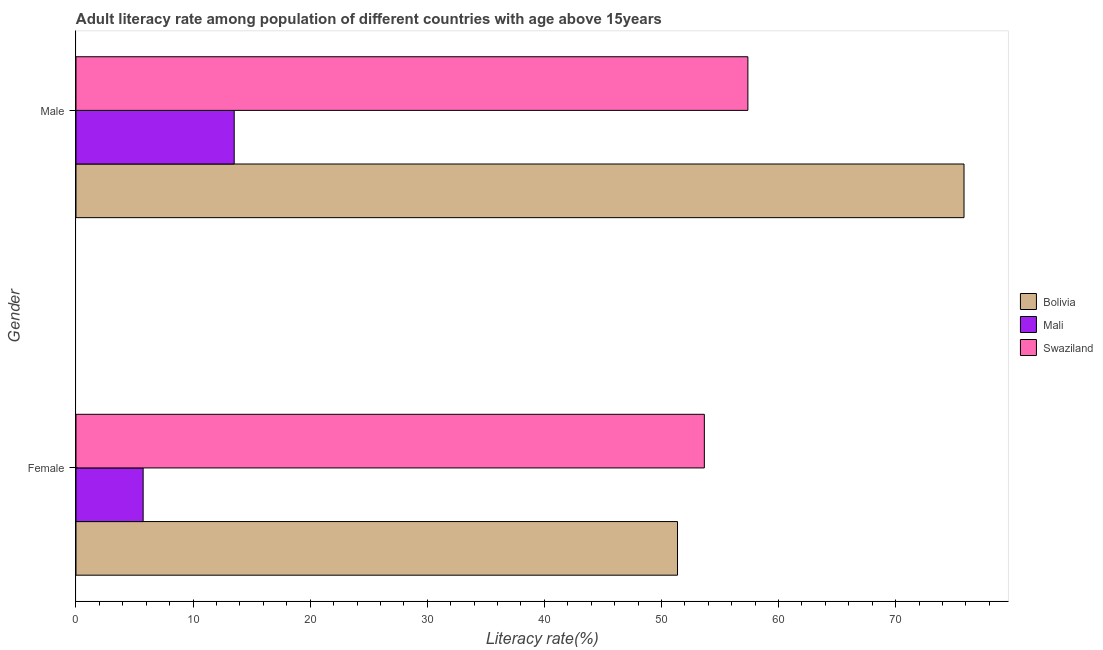How many groups of bars are there?
Keep it short and to the point. 2. Are the number of bars per tick equal to the number of legend labels?
Offer a very short reply. Yes. What is the female adult literacy rate in Mali?
Offer a terse response. 5.74. Across all countries, what is the maximum male adult literacy rate?
Offer a very short reply. 75.84. Across all countries, what is the minimum female adult literacy rate?
Make the answer very short. 5.74. In which country was the male adult literacy rate minimum?
Provide a short and direct response. Mali. What is the total male adult literacy rate in the graph?
Your answer should be compact. 146.74. What is the difference between the female adult literacy rate in Swaziland and that in Mali?
Ensure brevity in your answer.  47.93. What is the difference between the male adult literacy rate in Bolivia and the female adult literacy rate in Swaziland?
Offer a terse response. 22.18. What is the average male adult literacy rate per country?
Provide a succinct answer. 48.91. What is the difference between the male adult literacy rate and female adult literacy rate in Bolivia?
Ensure brevity in your answer.  24.47. What is the ratio of the female adult literacy rate in Swaziland to that in Mali?
Your answer should be very brief. 9.36. What does the 3rd bar from the top in Male represents?
Provide a short and direct response. Bolivia. What does the 2nd bar from the bottom in Female represents?
Ensure brevity in your answer.  Mali. How many countries are there in the graph?
Your answer should be very brief. 3. Does the graph contain any zero values?
Your answer should be compact. No. Where does the legend appear in the graph?
Make the answer very short. Center right. How are the legend labels stacked?
Your response must be concise. Vertical. What is the title of the graph?
Give a very brief answer. Adult literacy rate among population of different countries with age above 15years. What is the label or title of the X-axis?
Your answer should be compact. Literacy rate(%). What is the Literacy rate(%) of Bolivia in Female?
Offer a terse response. 51.37. What is the Literacy rate(%) in Mali in Female?
Offer a terse response. 5.74. What is the Literacy rate(%) in Swaziland in Female?
Keep it short and to the point. 53.67. What is the Literacy rate(%) in Bolivia in Male?
Ensure brevity in your answer.  75.84. What is the Literacy rate(%) of Mali in Male?
Your answer should be compact. 13.51. What is the Literacy rate(%) in Swaziland in Male?
Your answer should be compact. 57.38. Across all Gender, what is the maximum Literacy rate(%) in Bolivia?
Keep it short and to the point. 75.84. Across all Gender, what is the maximum Literacy rate(%) in Mali?
Offer a terse response. 13.51. Across all Gender, what is the maximum Literacy rate(%) in Swaziland?
Your response must be concise. 57.38. Across all Gender, what is the minimum Literacy rate(%) of Bolivia?
Provide a succinct answer. 51.37. Across all Gender, what is the minimum Literacy rate(%) in Mali?
Your answer should be very brief. 5.74. Across all Gender, what is the minimum Literacy rate(%) in Swaziland?
Provide a succinct answer. 53.67. What is the total Literacy rate(%) in Bolivia in the graph?
Provide a succinct answer. 127.22. What is the total Literacy rate(%) in Mali in the graph?
Provide a succinct answer. 19.25. What is the total Literacy rate(%) of Swaziland in the graph?
Your response must be concise. 111.05. What is the difference between the Literacy rate(%) in Bolivia in Female and that in Male?
Ensure brevity in your answer.  -24.47. What is the difference between the Literacy rate(%) in Mali in Female and that in Male?
Keep it short and to the point. -7.78. What is the difference between the Literacy rate(%) of Swaziland in Female and that in Male?
Your response must be concise. -3.72. What is the difference between the Literacy rate(%) in Bolivia in Female and the Literacy rate(%) in Mali in Male?
Make the answer very short. 37.86. What is the difference between the Literacy rate(%) of Bolivia in Female and the Literacy rate(%) of Swaziland in Male?
Provide a short and direct response. -6.01. What is the difference between the Literacy rate(%) of Mali in Female and the Literacy rate(%) of Swaziland in Male?
Keep it short and to the point. -51.65. What is the average Literacy rate(%) in Bolivia per Gender?
Your answer should be compact. 63.61. What is the average Literacy rate(%) of Mali per Gender?
Your answer should be compact. 9.62. What is the average Literacy rate(%) of Swaziland per Gender?
Your answer should be compact. 55.53. What is the difference between the Literacy rate(%) of Bolivia and Literacy rate(%) of Mali in Female?
Give a very brief answer. 45.64. What is the difference between the Literacy rate(%) in Bolivia and Literacy rate(%) in Swaziland in Female?
Provide a short and direct response. -2.29. What is the difference between the Literacy rate(%) in Mali and Literacy rate(%) in Swaziland in Female?
Offer a terse response. -47.93. What is the difference between the Literacy rate(%) of Bolivia and Literacy rate(%) of Mali in Male?
Offer a very short reply. 62.33. What is the difference between the Literacy rate(%) in Bolivia and Literacy rate(%) in Swaziland in Male?
Your answer should be compact. 18.46. What is the difference between the Literacy rate(%) in Mali and Literacy rate(%) in Swaziland in Male?
Offer a very short reply. -43.87. What is the ratio of the Literacy rate(%) of Bolivia in Female to that in Male?
Ensure brevity in your answer.  0.68. What is the ratio of the Literacy rate(%) in Mali in Female to that in Male?
Your response must be concise. 0.42. What is the ratio of the Literacy rate(%) in Swaziland in Female to that in Male?
Offer a terse response. 0.94. What is the difference between the highest and the second highest Literacy rate(%) in Bolivia?
Provide a short and direct response. 24.47. What is the difference between the highest and the second highest Literacy rate(%) in Mali?
Ensure brevity in your answer.  7.78. What is the difference between the highest and the second highest Literacy rate(%) in Swaziland?
Your answer should be compact. 3.72. What is the difference between the highest and the lowest Literacy rate(%) of Bolivia?
Give a very brief answer. 24.47. What is the difference between the highest and the lowest Literacy rate(%) in Mali?
Your response must be concise. 7.78. What is the difference between the highest and the lowest Literacy rate(%) of Swaziland?
Keep it short and to the point. 3.72. 